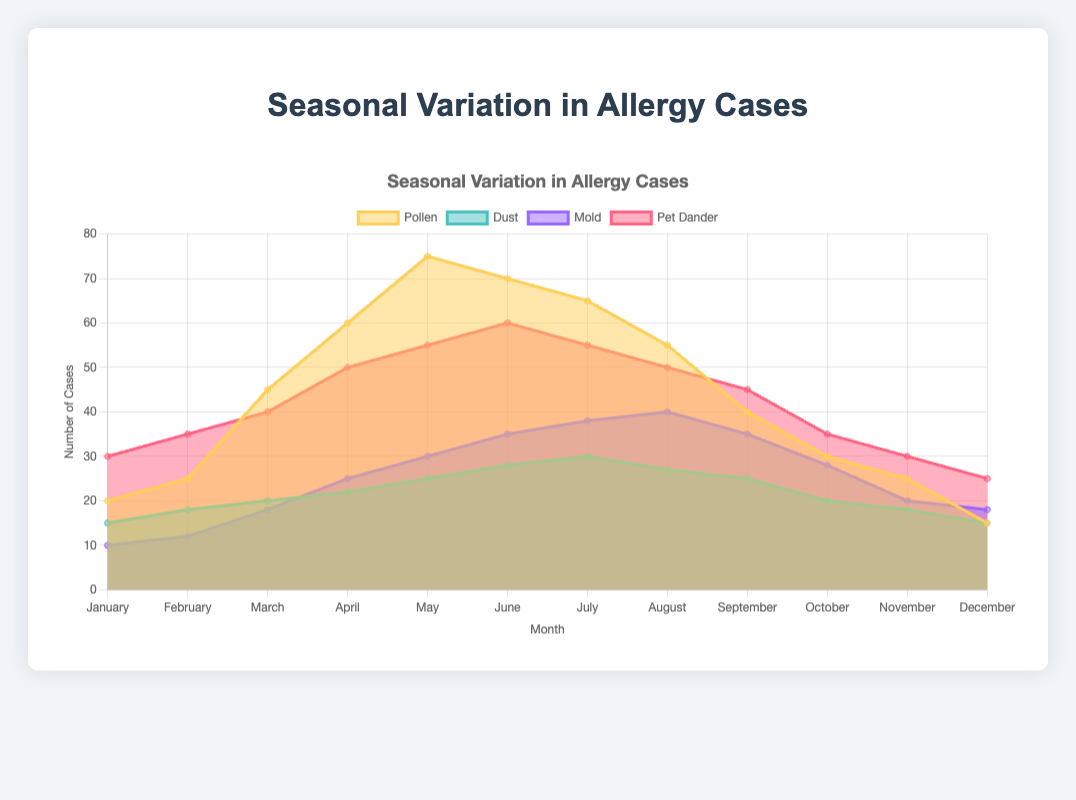What is the title of the chart? The title is displayed at the top of the chart and reads "Seasonal Variation in Allergy Cases".
Answer: Seasonal Variation in Allergy Cases Which allergen consistently shows the highest number of cases throughout the year? By looking at the height of the areas in the area chart, Pet Dander consistently has the highest number of cases every month.
Answer: Pet Dander In which month are pollen allergy cases at their peak? Pollen allergy cases peak at the highest point on the yellow area. This occurs in May.
Answer: May Which allergen has the greatest increase in cases from January to March? Compare the height differences in the starting and ending months for each allergen from January to March. Pollen increases from 20 to 45, which is the largest increase (+25 cases).
Answer: Pollen During which month do mold allergy cases reach their highest count? The height of the purple area is highest in August. Therefore, August has the highest mold cases.
Answer: August What is the combined number of allergy cases for all allergens in June? Add the values for all allergens in June: Pollen (70) + Dust (28) + Mold (35) + Pet Dander (60) = 193.
Answer: 193 When comparing June and December, which month has fewer total allergy cases? Sum the allergy cases for each month: June (193) and December (73). December has fewer cases.
Answer: December By how many cases does pet dander decrease from July to October? Subtract the number of cases in October (35) from July (55). The decrease is 20 cases.
Answer: 20 What is the average number of dust allergy cases over the year? Sum the dust cases for all months and divide by 12: (15 + 18 + 20 + 22 + 25 + 28 + 30 + 27 + 25 + 20 + 18 + 15) / 12 = 253 / 12 ≈ 21.08.
Answer: 21.08 Which month shows the lowest number of mold allergy cases? The shortest height of the purple area is in January, indicating the lowest number of cases, which is 10.
Answer: January 